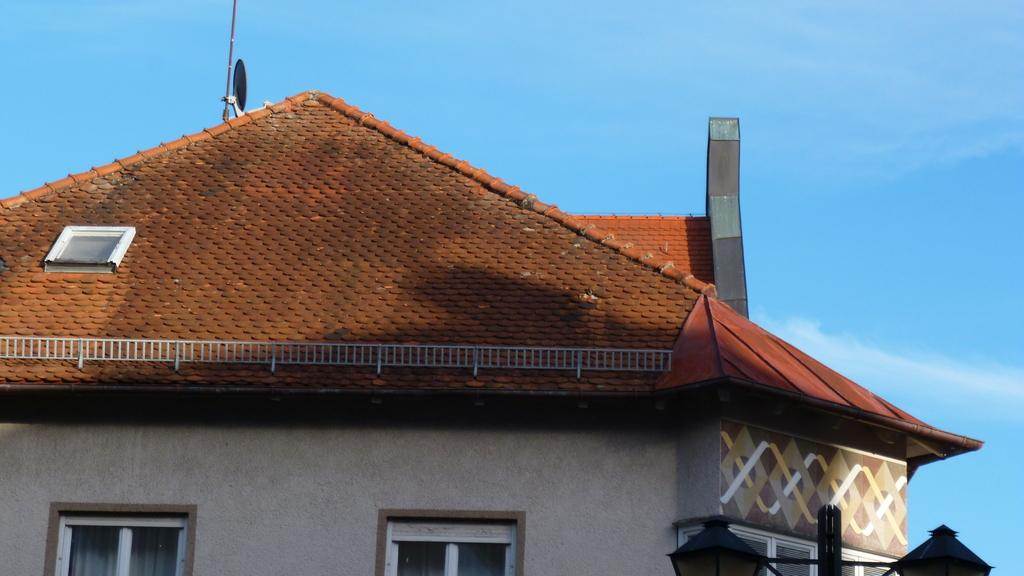What type of structure is present in the image? There is a house in the image. Can you describe any additional features near the house? Lamps are attached to a pole in the right bottom of the image. What can be seen in the background of the image? The sky is visible in the background of the image. How many sheets of paper are being used to create the heat in the image? There is no paper or heat present in the image. What type of account is being managed by the person in the image? There is no person or account present in the image. 